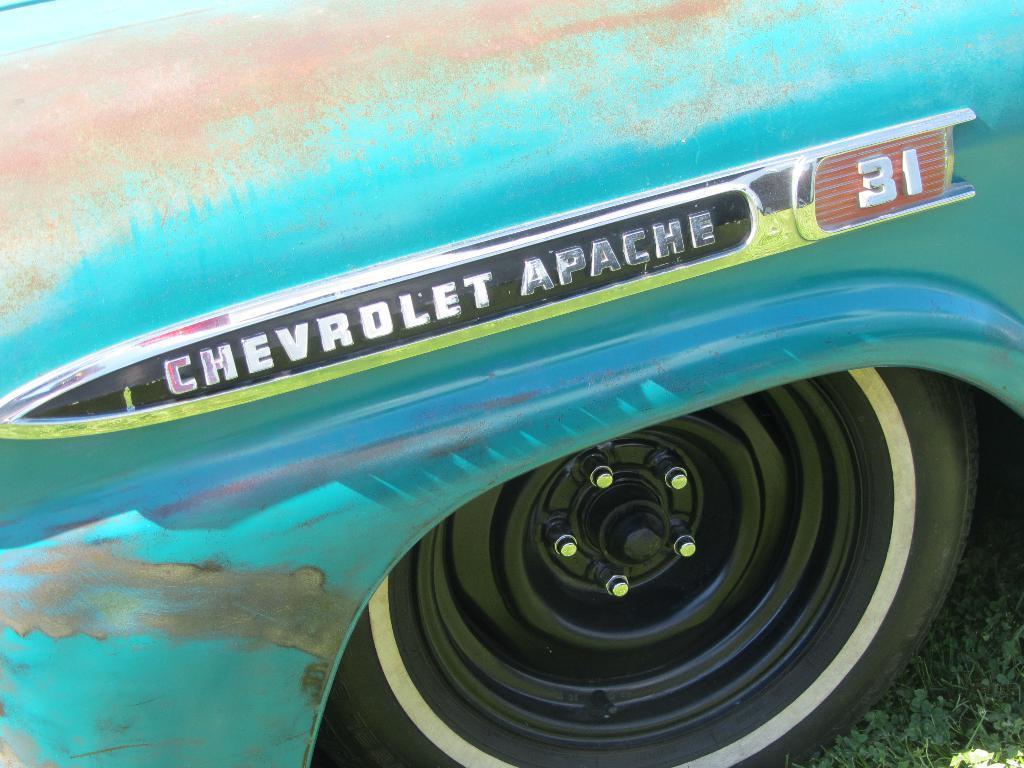How would you summarize this image in a sentence or two? In this picture we can see a wheel of a vehicle on the grass and some text. 